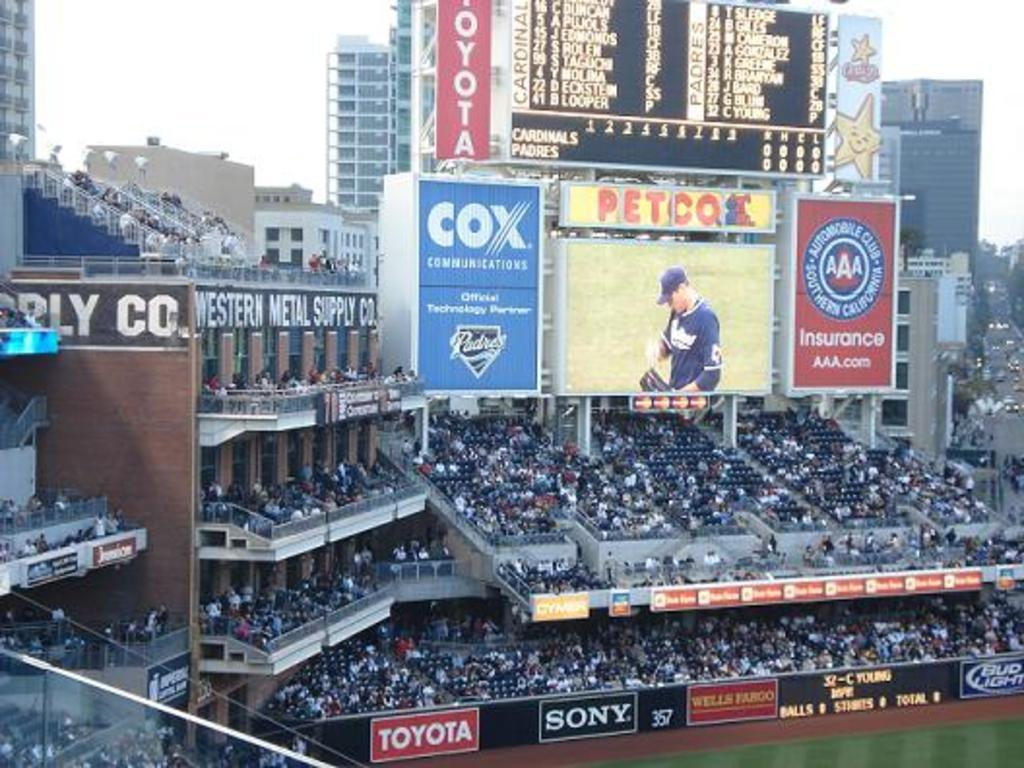<image>
Write a terse but informative summary of the picture. Baseball stadium screen with Cox Communications, AAA Insurance, Toyota, and Petco as sponsors. 